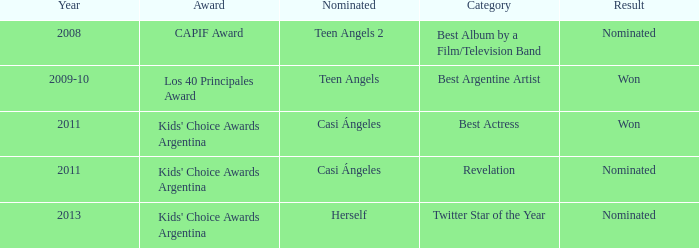What year saw an award in the category of Revelation? 2011.0. 